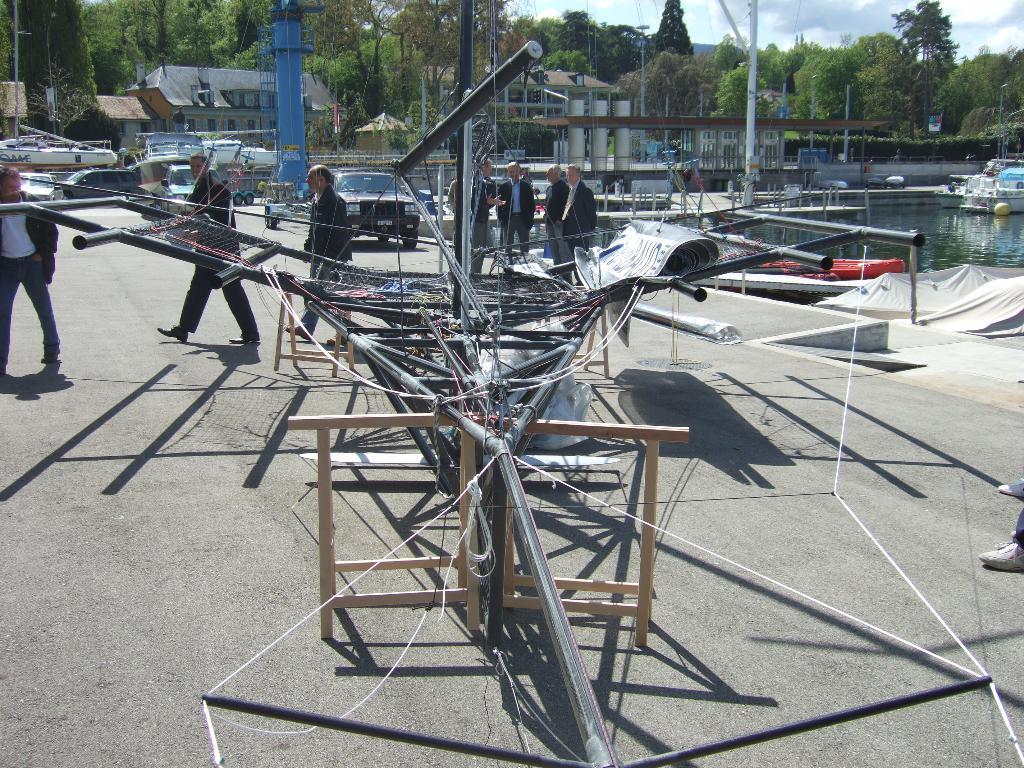In one or two sentences, can you explain what this image depicts? In this picture we can see metal rods in the front, on the right side we can see water and boats, there are some vehicles and few persons in the middle, in the background there are trees and buildings, we can see the sky at the right top of the picture. 